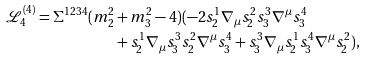Convert formula to latex. <formula><loc_0><loc_0><loc_500><loc_500>\mathcal { L } ^ { ( 4 ) } _ { 4 } = \Sigma ^ { 1 2 3 4 } ( m _ { 2 } ^ { 2 } & + m _ { 3 } ^ { 2 } - 4 ) ( - 2 s _ { 2 } ^ { 1 } \nabla _ { \mu } s _ { 2 } ^ { 2 } s _ { 3 } ^ { 3 } \nabla ^ { \mu } s _ { 3 } ^ { 4 } \\ & + s _ { 2 } ^ { 1 } \nabla _ { \mu } s _ { 3 } ^ { 3 } s _ { 2 } ^ { 2 } \nabla ^ { \mu } s _ { 3 } ^ { 4 } + s _ { 3 } ^ { 3 } \nabla _ { \mu } s _ { 2 } ^ { 1 } s _ { 3 } ^ { 4 } \nabla ^ { \mu } s _ { 2 } ^ { 2 } ) ,</formula> 